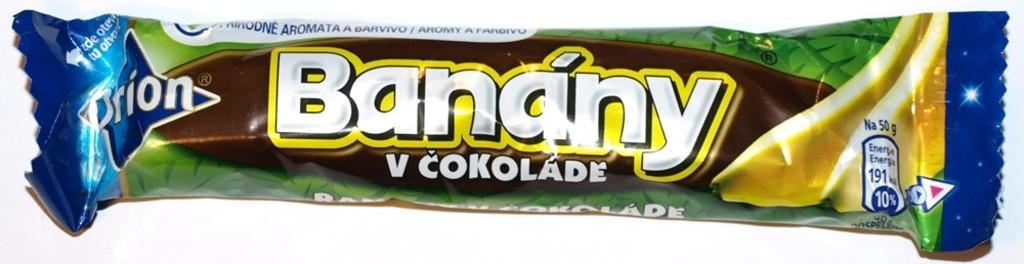In one or two sentences, can you explain what this image depicts? In this image I can see a chocolate packet on the white surface.   